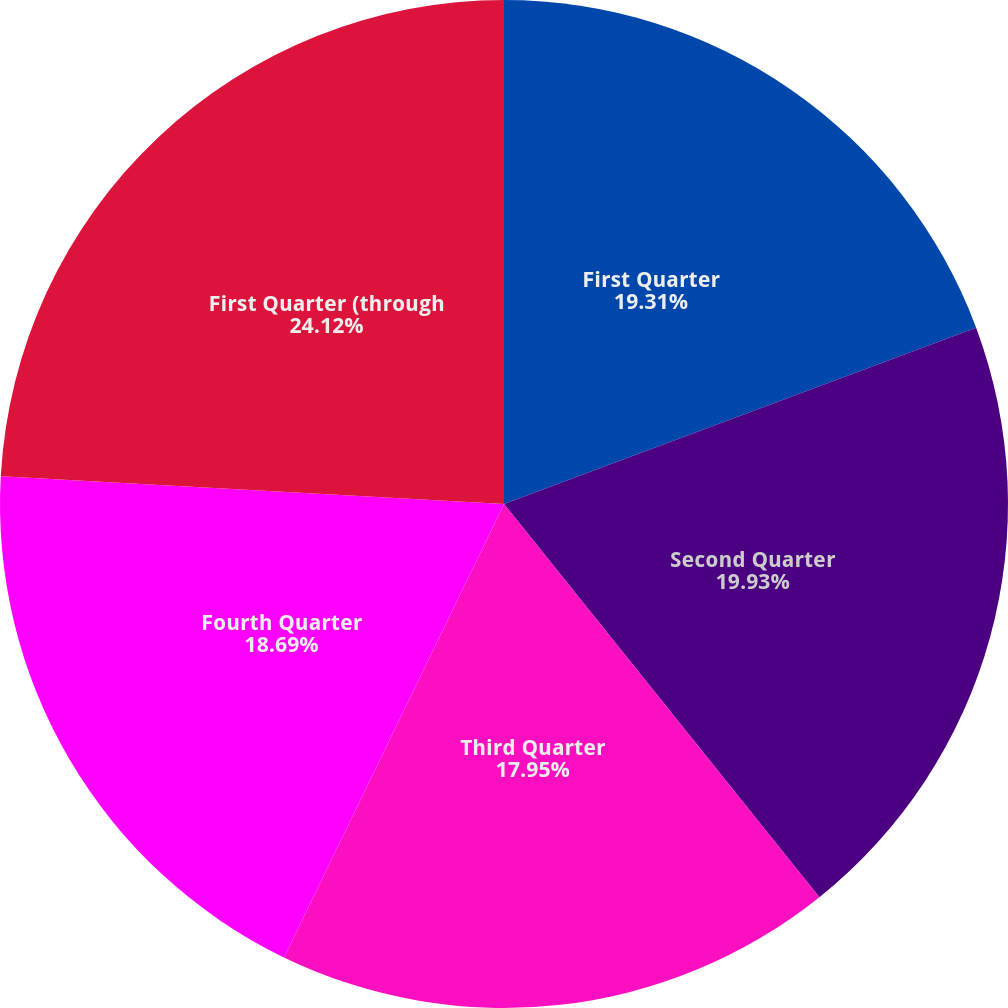<chart> <loc_0><loc_0><loc_500><loc_500><pie_chart><fcel>First Quarter<fcel>Second Quarter<fcel>Third Quarter<fcel>Fourth Quarter<fcel>First Quarter (through<nl><fcel>19.31%<fcel>19.93%<fcel>17.95%<fcel>18.69%<fcel>24.12%<nl></chart> 